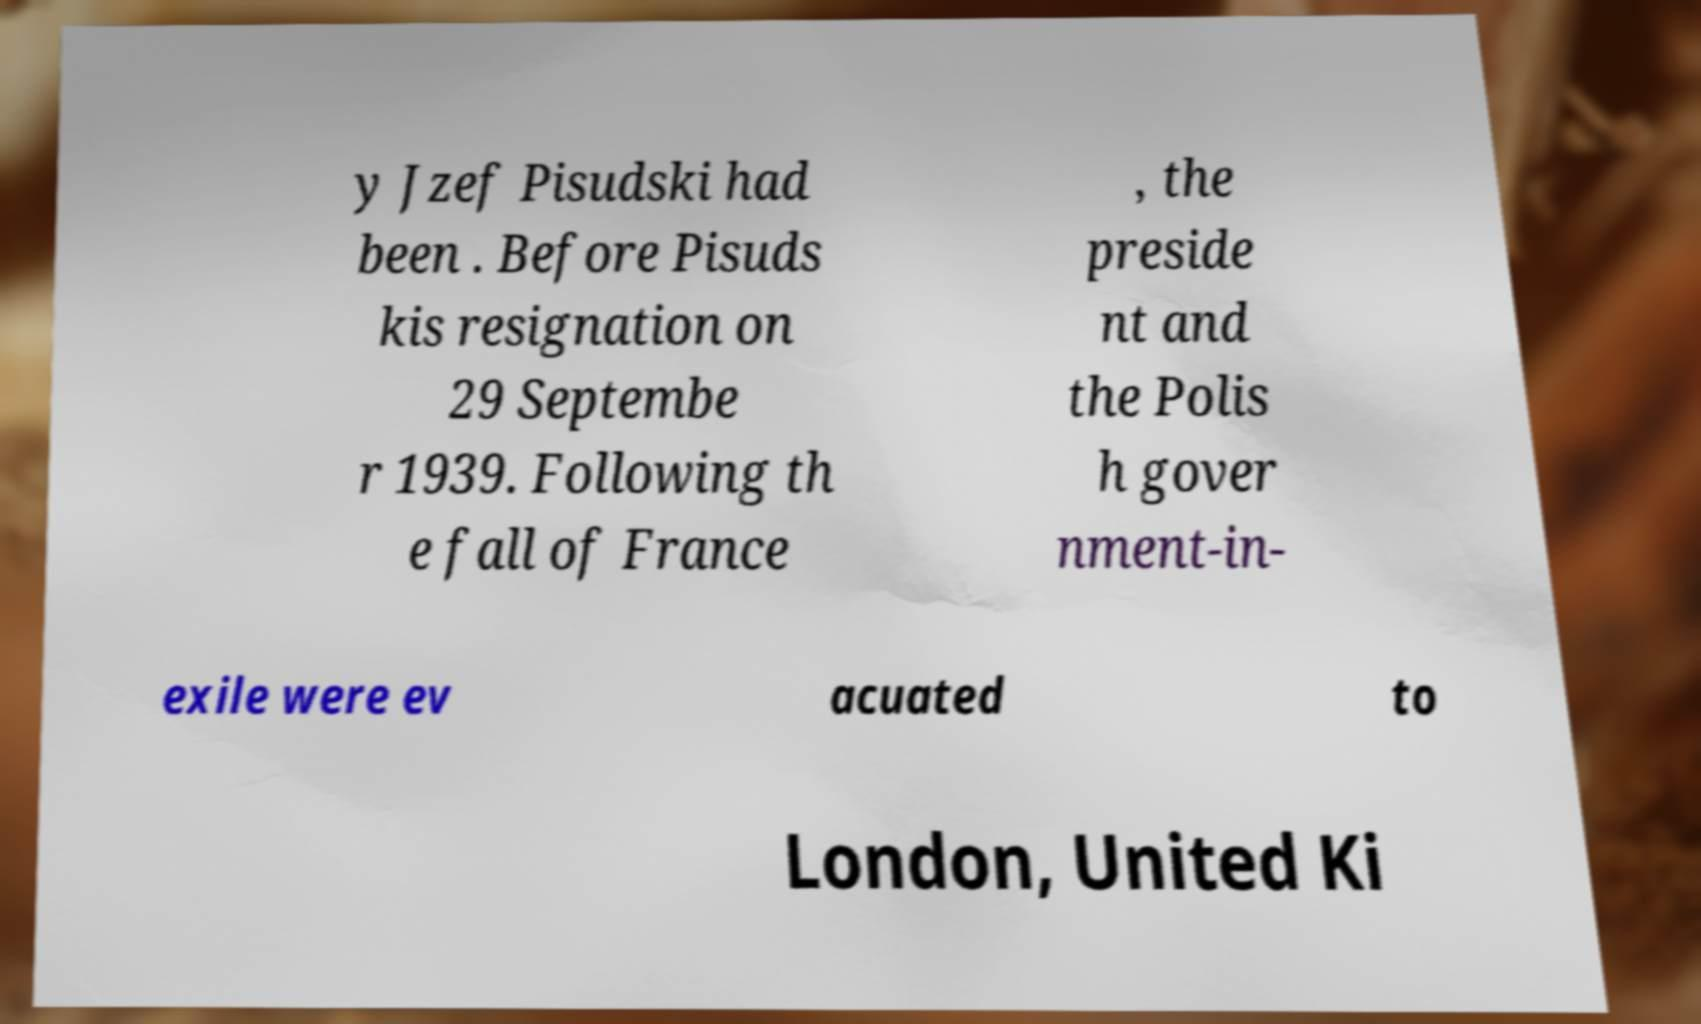There's text embedded in this image that I need extracted. Can you transcribe it verbatim? y Jzef Pisudski had been . Before Pisuds kis resignation on 29 Septembe r 1939. Following th e fall of France , the preside nt and the Polis h gover nment-in- exile were ev acuated to London, United Ki 